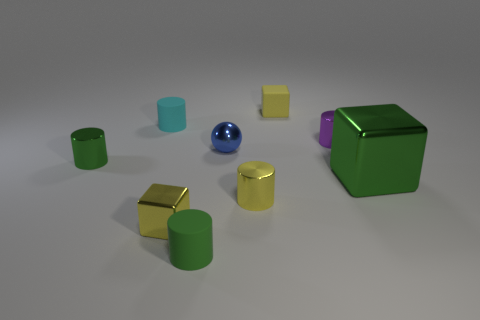Subtract 2 cylinders. How many cylinders are left? 3 Subtract all cylinders. How many objects are left? 4 Subtract all big yellow metal spheres. Subtract all blue shiny balls. How many objects are left? 8 Add 6 small cubes. How many small cubes are left? 8 Add 4 blue metallic cubes. How many blue metallic cubes exist? 4 Subtract 0 gray blocks. How many objects are left? 9 